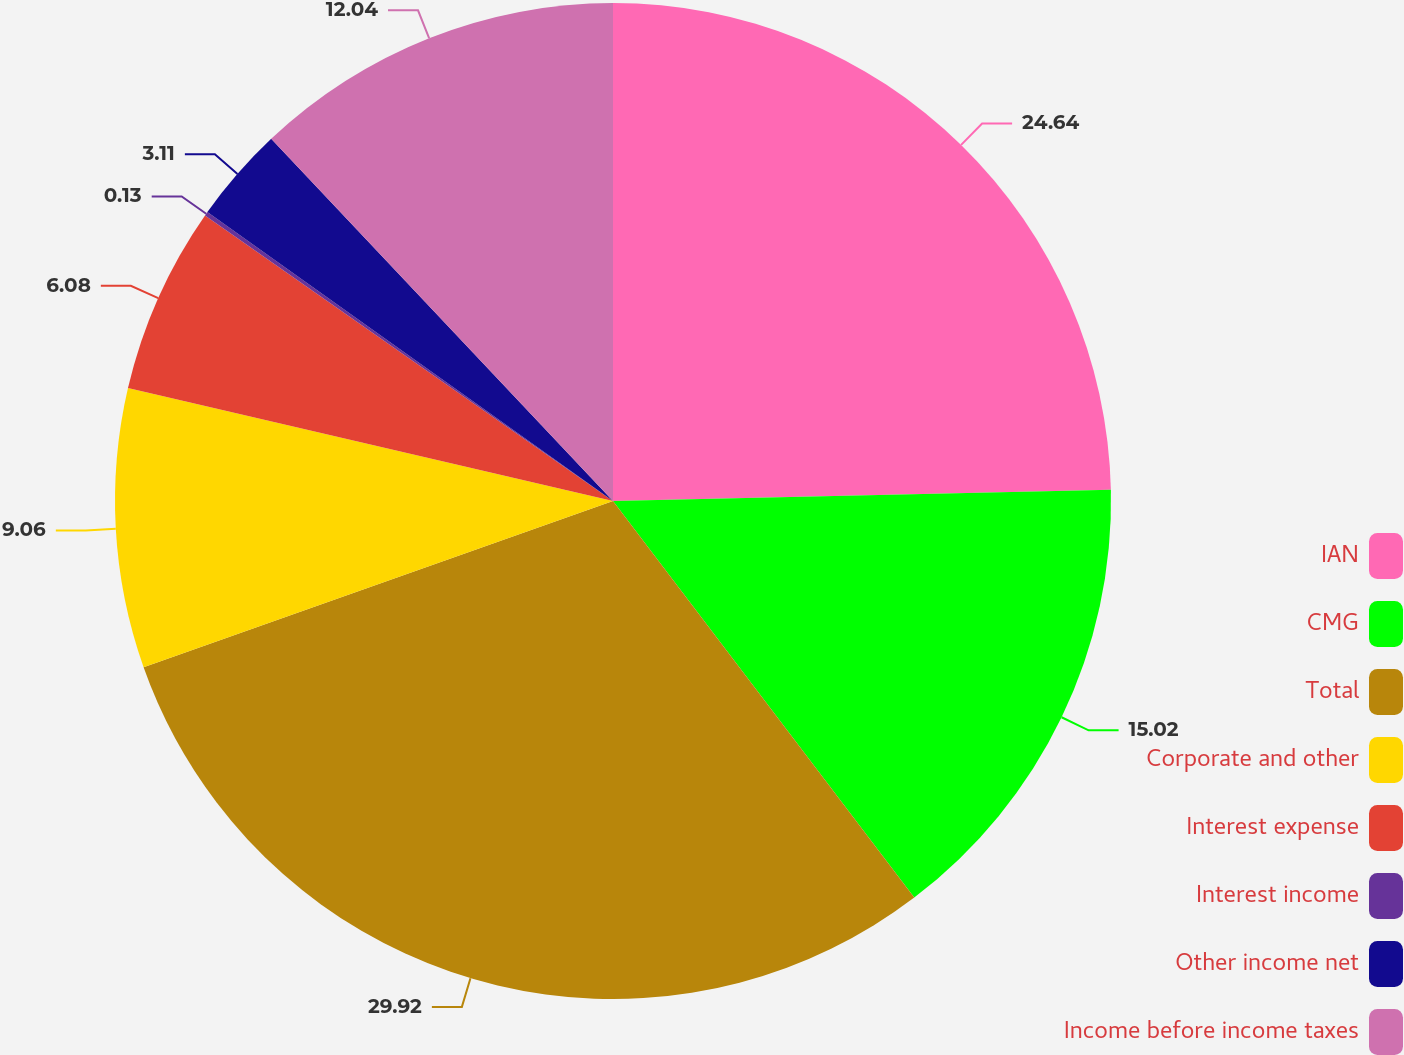<chart> <loc_0><loc_0><loc_500><loc_500><pie_chart><fcel>IAN<fcel>CMG<fcel>Total<fcel>Corporate and other<fcel>Interest expense<fcel>Interest income<fcel>Other income net<fcel>Income before income taxes<nl><fcel>24.64%<fcel>15.02%<fcel>29.92%<fcel>9.06%<fcel>6.08%<fcel>0.13%<fcel>3.11%<fcel>12.04%<nl></chart> 